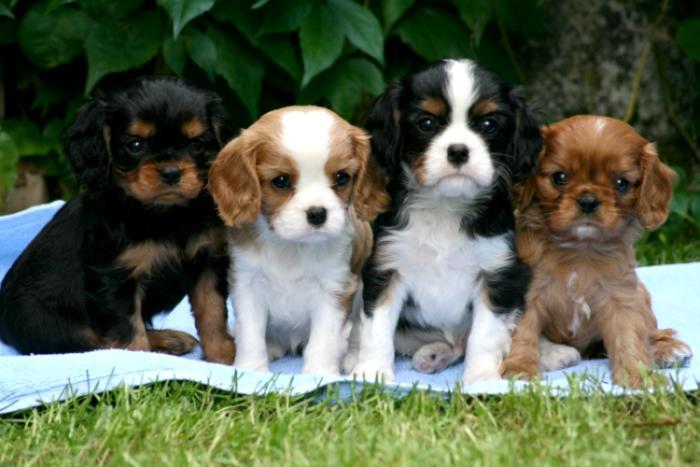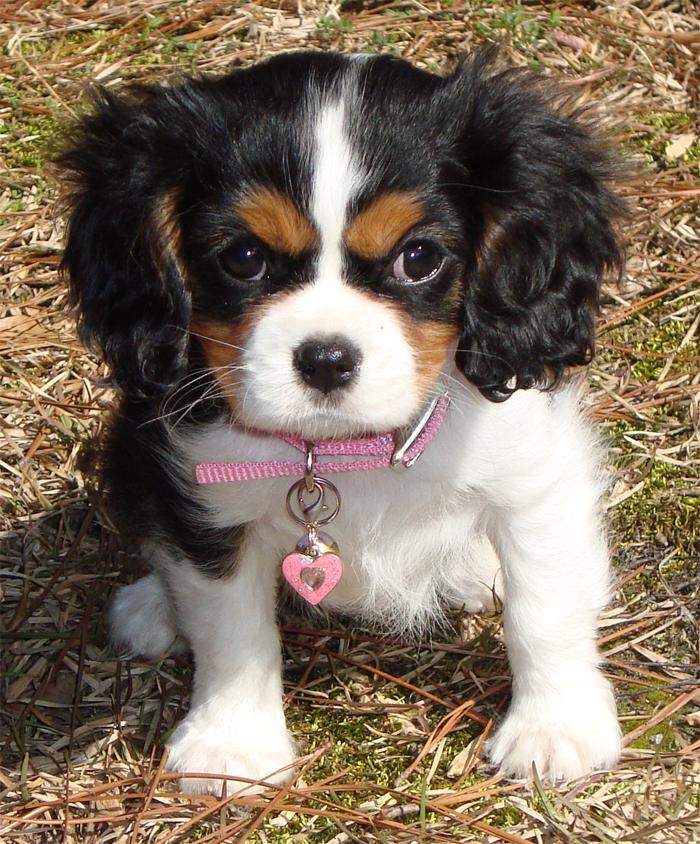The first image is the image on the left, the second image is the image on the right. Considering the images on both sides, is "An image shows exactly two look-alike puppies." valid? Answer yes or no. No. 